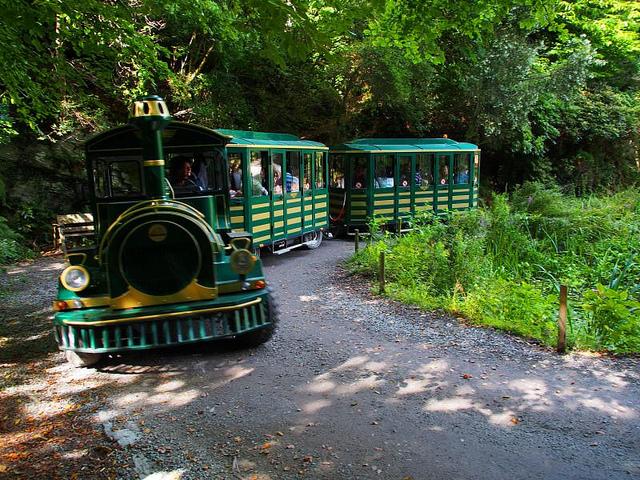Is this a real train?
Give a very brief answer. No. What is the train riding on?
Keep it brief. Ground. Is this a fast train?
Write a very short answer. No. Does this train have a caboose?
Concise answer only. No. 